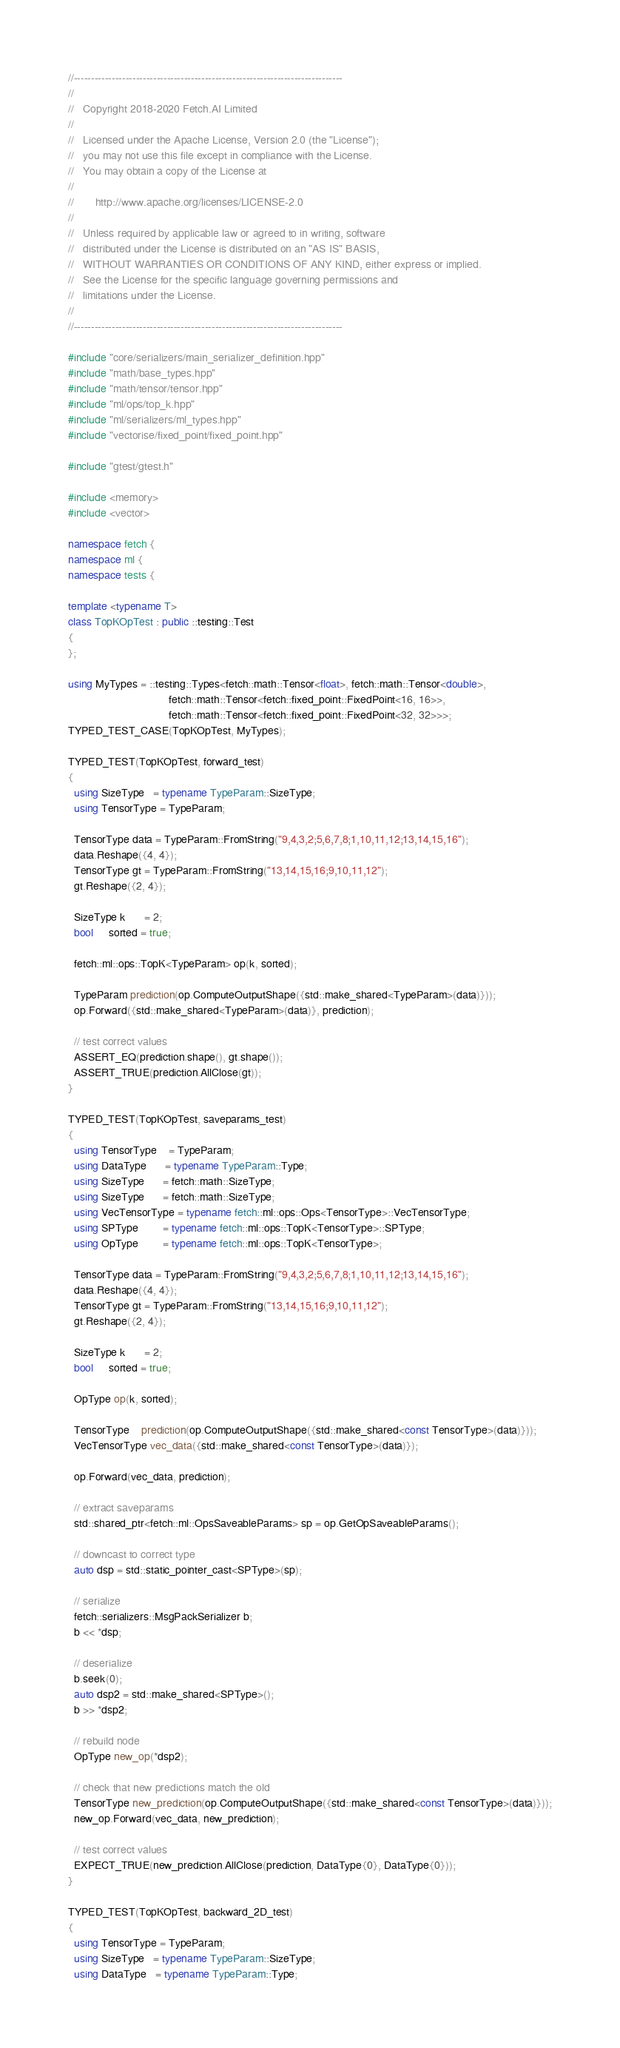Convert code to text. <code><loc_0><loc_0><loc_500><loc_500><_C++_>//------------------------------------------------------------------------------
//
//   Copyright 2018-2020 Fetch.AI Limited
//
//   Licensed under the Apache License, Version 2.0 (the "License");
//   you may not use this file except in compliance with the License.
//   You may obtain a copy of the License at
//
//       http://www.apache.org/licenses/LICENSE-2.0
//
//   Unless required by applicable law or agreed to in writing, software
//   distributed under the License is distributed on an "AS IS" BASIS,
//   WITHOUT WARRANTIES OR CONDITIONS OF ANY KIND, either express or implied.
//   See the License for the specific language governing permissions and
//   limitations under the License.
//
//------------------------------------------------------------------------------

#include "core/serializers/main_serializer_definition.hpp"
#include "math/base_types.hpp"
#include "math/tensor/tensor.hpp"
#include "ml/ops/top_k.hpp"
#include "ml/serializers/ml_types.hpp"
#include "vectorise/fixed_point/fixed_point.hpp"

#include "gtest/gtest.h"

#include <memory>
#include <vector>

namespace fetch {
namespace ml {
namespace tests {

template <typename T>
class TopKOpTest : public ::testing::Test
{
};

using MyTypes = ::testing::Types<fetch::math::Tensor<float>, fetch::math::Tensor<double>,
                                 fetch::math::Tensor<fetch::fixed_point::FixedPoint<16, 16>>,
                                 fetch::math::Tensor<fetch::fixed_point::FixedPoint<32, 32>>>;
TYPED_TEST_CASE(TopKOpTest, MyTypes);

TYPED_TEST(TopKOpTest, forward_test)
{
  using SizeType   = typename TypeParam::SizeType;
  using TensorType = TypeParam;

  TensorType data = TypeParam::FromString("9,4,3,2;5,6,7,8;1,10,11,12;13,14,15,16");
  data.Reshape({4, 4});
  TensorType gt = TypeParam::FromString("13,14,15,16;9,10,11,12");
  gt.Reshape({2, 4});

  SizeType k      = 2;
  bool     sorted = true;

  fetch::ml::ops::TopK<TypeParam> op(k, sorted);

  TypeParam prediction(op.ComputeOutputShape({std::make_shared<TypeParam>(data)}));
  op.Forward({std::make_shared<TypeParam>(data)}, prediction);

  // test correct values
  ASSERT_EQ(prediction.shape(), gt.shape());
  ASSERT_TRUE(prediction.AllClose(gt));
}

TYPED_TEST(TopKOpTest, saveparams_test)
{
  using TensorType    = TypeParam;
  using DataType      = typename TypeParam::Type;
  using SizeType      = fetch::math::SizeType;
  using SizeType      = fetch::math::SizeType;
  using VecTensorType = typename fetch::ml::ops::Ops<TensorType>::VecTensorType;
  using SPType        = typename fetch::ml::ops::TopK<TensorType>::SPType;
  using OpType        = typename fetch::ml::ops::TopK<TensorType>;

  TensorType data = TypeParam::FromString("9,4,3,2;5,6,7,8;1,10,11,12;13,14,15,16");
  data.Reshape({4, 4});
  TensorType gt = TypeParam::FromString("13,14,15,16;9,10,11,12");
  gt.Reshape({2, 4});

  SizeType k      = 2;
  bool     sorted = true;

  OpType op(k, sorted);

  TensorType    prediction(op.ComputeOutputShape({std::make_shared<const TensorType>(data)}));
  VecTensorType vec_data({std::make_shared<const TensorType>(data)});

  op.Forward(vec_data, prediction);

  // extract saveparams
  std::shared_ptr<fetch::ml::OpsSaveableParams> sp = op.GetOpSaveableParams();

  // downcast to correct type
  auto dsp = std::static_pointer_cast<SPType>(sp);

  // serialize
  fetch::serializers::MsgPackSerializer b;
  b << *dsp;

  // deserialize
  b.seek(0);
  auto dsp2 = std::make_shared<SPType>();
  b >> *dsp2;

  // rebuild node
  OpType new_op(*dsp2);

  // check that new predictions match the old
  TensorType new_prediction(op.ComputeOutputShape({std::make_shared<const TensorType>(data)}));
  new_op.Forward(vec_data, new_prediction);

  // test correct values
  EXPECT_TRUE(new_prediction.AllClose(prediction, DataType{0}, DataType{0}));
}

TYPED_TEST(TopKOpTest, backward_2D_test)
{
  using TensorType = TypeParam;
  using SizeType   = typename TypeParam::SizeType;
  using DataType   = typename TypeParam::Type;
</code> 